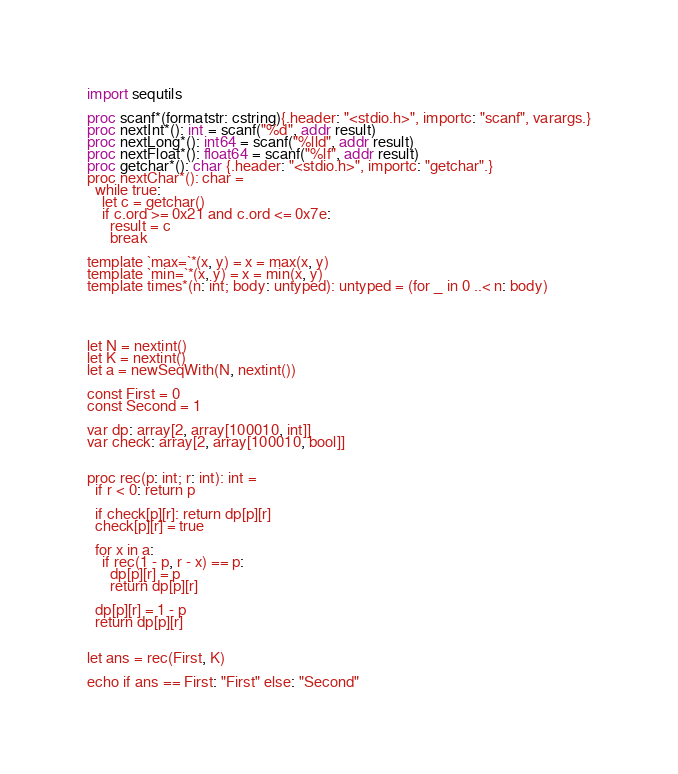Convert code to text. <code><loc_0><loc_0><loc_500><loc_500><_Nim_>import sequtils

proc scanf*(formatstr: cstring){.header: "<stdio.h>", importc: "scanf", varargs.}
proc nextInt*(): int = scanf("%d", addr result)
proc nextLong*(): int64 = scanf("%lld", addr result)
proc nextFloat*(): float64 = scanf("%lf", addr result)
proc getchar*(): char {.header: "<stdio.h>", importc: "getchar".}
proc nextChar*(): char =
  while true:
    let c = getchar()
    if c.ord >= 0x21 and c.ord <= 0x7e:
      result = c
      break

template `max=`*(x, y) = x = max(x, y)
template `min=`*(x, y) = x = min(x, y)
template times*(n: int; body: untyped): untyped = (for _ in 0 ..< n: body)




let N = nextint()
let K = nextint()
let a = newSeqWith(N, nextint())

const First = 0
const Second = 1

var dp: array[2, array[100010, int]]
var check: array[2, array[100010, bool]]


proc rec(p: int; r: int): int =
  if r < 0: return p

  if check[p][r]: return dp[p][r]
  check[p][r] = true

  for x in a:
    if rec(1 - p, r - x) == p:
      dp[p][r] = p
      return dp[p][r]

  dp[p][r] = 1 - p
  return dp[p][r]


let ans = rec(First, K)

echo if ans == First: "First" else: "Second"
</code> 